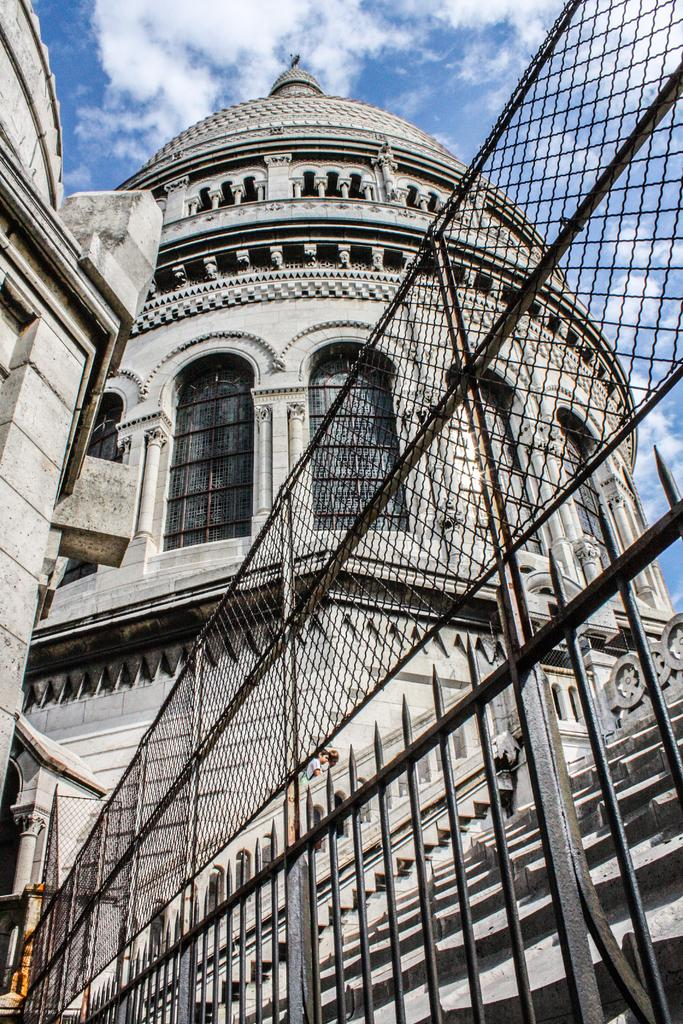What type of structure can be seen in the image? There is a fence in the image. What can be seen in the distance behind the fence? There is a building and windows visible in the background of the image. What architectural feature is present in the background of the image? There is a railing in the background of the image. What is visible in the sky in the background of the image? Clouds are present in the sky in the background of the image. What type of guitar can be seen hanging on the fence in the image? There is no guitar present in the image; it only features a fence, a building, windows, a railing, and clouds. 